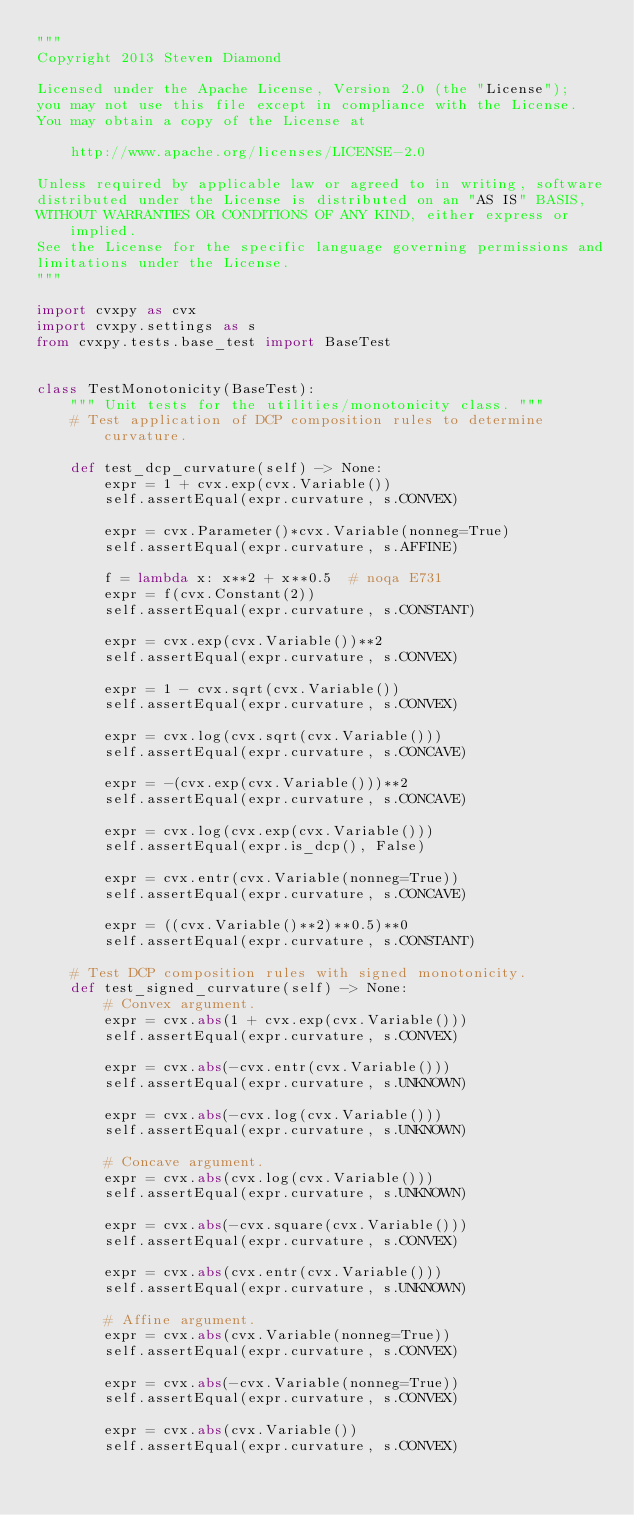Convert code to text. <code><loc_0><loc_0><loc_500><loc_500><_Python_>"""
Copyright 2013 Steven Diamond

Licensed under the Apache License, Version 2.0 (the "License");
you may not use this file except in compliance with the License.
You may obtain a copy of the License at

    http://www.apache.org/licenses/LICENSE-2.0

Unless required by applicable law or agreed to in writing, software
distributed under the License is distributed on an "AS IS" BASIS,
WITHOUT WARRANTIES OR CONDITIONS OF ANY KIND, either express or implied.
See the License for the specific language governing permissions and
limitations under the License.
"""

import cvxpy as cvx
import cvxpy.settings as s
from cvxpy.tests.base_test import BaseTest


class TestMonotonicity(BaseTest):
    """ Unit tests for the utilities/monotonicity class. """
    # Test application of DCP composition rules to determine curvature.

    def test_dcp_curvature(self) -> None:
        expr = 1 + cvx.exp(cvx.Variable())
        self.assertEqual(expr.curvature, s.CONVEX)

        expr = cvx.Parameter()*cvx.Variable(nonneg=True)
        self.assertEqual(expr.curvature, s.AFFINE)

        f = lambda x: x**2 + x**0.5  # noqa E731
        expr = f(cvx.Constant(2))
        self.assertEqual(expr.curvature, s.CONSTANT)

        expr = cvx.exp(cvx.Variable())**2
        self.assertEqual(expr.curvature, s.CONVEX)

        expr = 1 - cvx.sqrt(cvx.Variable())
        self.assertEqual(expr.curvature, s.CONVEX)

        expr = cvx.log(cvx.sqrt(cvx.Variable()))
        self.assertEqual(expr.curvature, s.CONCAVE)

        expr = -(cvx.exp(cvx.Variable()))**2
        self.assertEqual(expr.curvature, s.CONCAVE)

        expr = cvx.log(cvx.exp(cvx.Variable()))
        self.assertEqual(expr.is_dcp(), False)

        expr = cvx.entr(cvx.Variable(nonneg=True))
        self.assertEqual(expr.curvature, s.CONCAVE)

        expr = ((cvx.Variable()**2)**0.5)**0
        self.assertEqual(expr.curvature, s.CONSTANT)

    # Test DCP composition rules with signed monotonicity.
    def test_signed_curvature(self) -> None:
        # Convex argument.
        expr = cvx.abs(1 + cvx.exp(cvx.Variable()))
        self.assertEqual(expr.curvature, s.CONVEX)

        expr = cvx.abs(-cvx.entr(cvx.Variable()))
        self.assertEqual(expr.curvature, s.UNKNOWN)

        expr = cvx.abs(-cvx.log(cvx.Variable()))
        self.assertEqual(expr.curvature, s.UNKNOWN)

        # Concave argument.
        expr = cvx.abs(cvx.log(cvx.Variable()))
        self.assertEqual(expr.curvature, s.UNKNOWN)

        expr = cvx.abs(-cvx.square(cvx.Variable()))
        self.assertEqual(expr.curvature, s.CONVEX)

        expr = cvx.abs(cvx.entr(cvx.Variable()))
        self.assertEqual(expr.curvature, s.UNKNOWN)

        # Affine argument.
        expr = cvx.abs(cvx.Variable(nonneg=True))
        self.assertEqual(expr.curvature, s.CONVEX)

        expr = cvx.abs(-cvx.Variable(nonneg=True))
        self.assertEqual(expr.curvature, s.CONVEX)

        expr = cvx.abs(cvx.Variable())
        self.assertEqual(expr.curvature, s.CONVEX)
</code> 